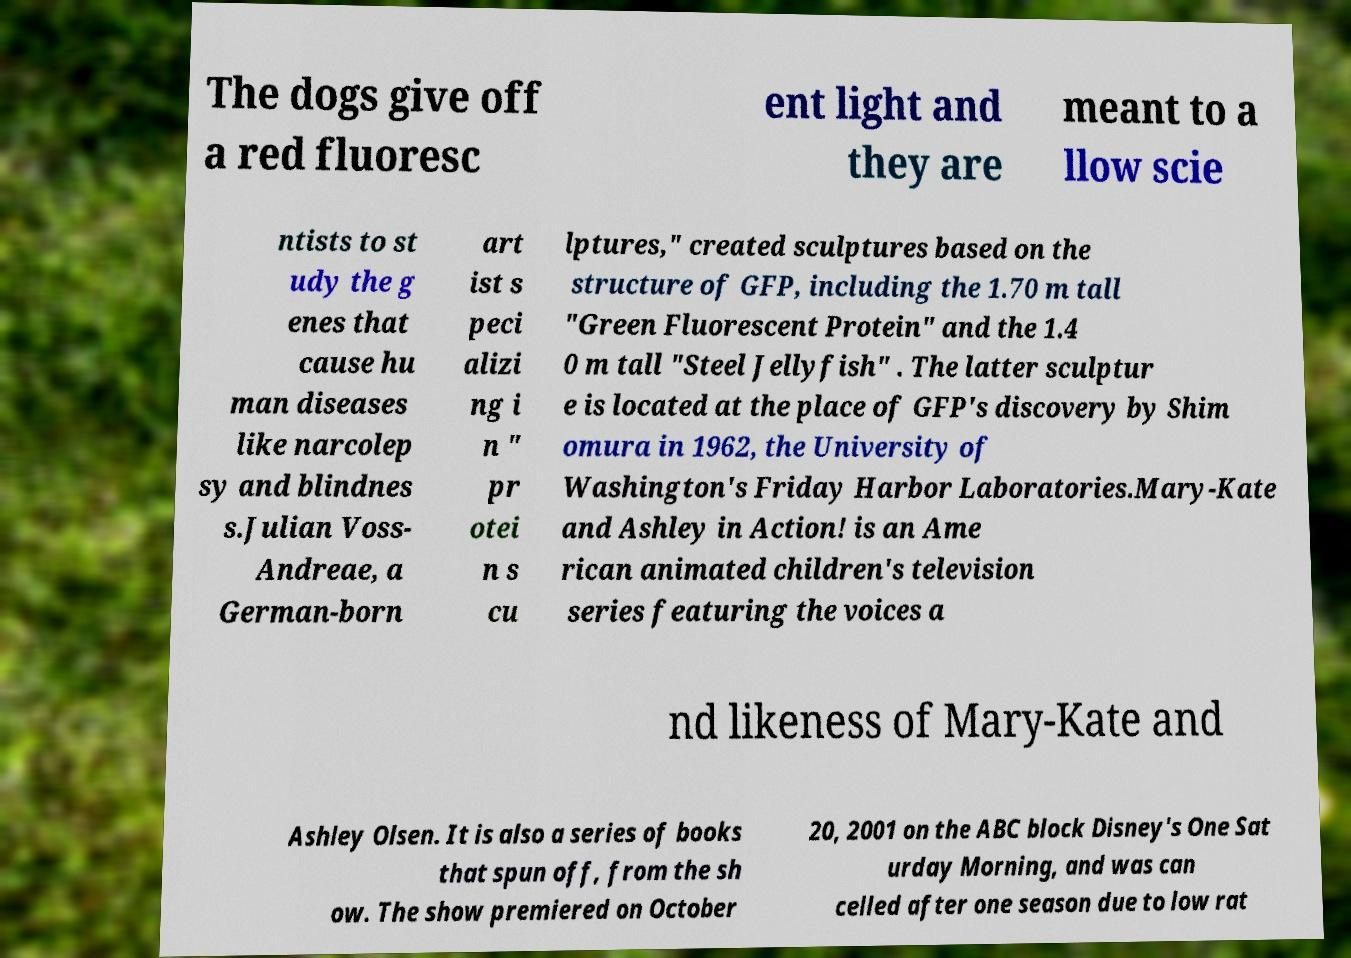I need the written content from this picture converted into text. Can you do that? The dogs give off a red fluoresc ent light and they are meant to a llow scie ntists to st udy the g enes that cause hu man diseases like narcolep sy and blindnes s.Julian Voss- Andreae, a German-born art ist s peci alizi ng i n " pr otei n s cu lptures," created sculptures based on the structure of GFP, including the 1.70 m tall "Green Fluorescent Protein" and the 1.4 0 m tall "Steel Jellyfish" . The latter sculptur e is located at the place of GFP's discovery by Shim omura in 1962, the University of Washington's Friday Harbor Laboratories.Mary-Kate and Ashley in Action! is an Ame rican animated children's television series featuring the voices a nd likeness of Mary-Kate and Ashley Olsen. It is also a series of books that spun off, from the sh ow. The show premiered on October 20, 2001 on the ABC block Disney's One Sat urday Morning, and was can celled after one season due to low rat 